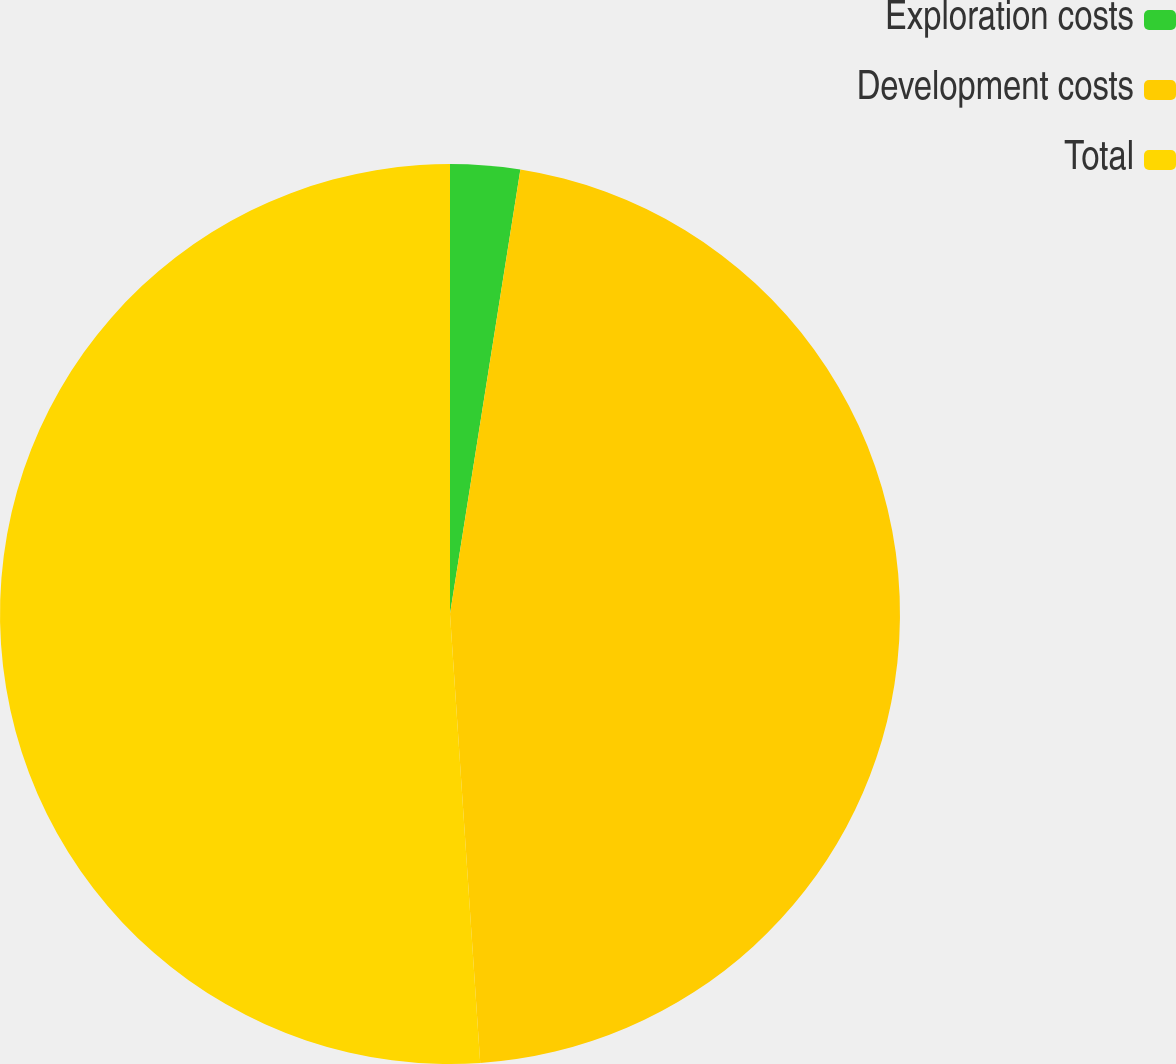Convert chart to OTSL. <chart><loc_0><loc_0><loc_500><loc_500><pie_chart><fcel>Exploration costs<fcel>Development costs<fcel>Total<nl><fcel>2.5%<fcel>46.43%<fcel>51.07%<nl></chart> 